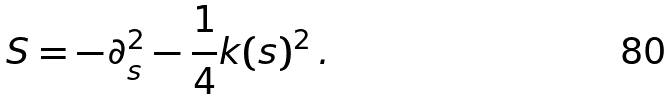<formula> <loc_0><loc_0><loc_500><loc_500>S = - \partial _ { s } ^ { 2 } - \frac { 1 } { 4 } k ( s ) ^ { 2 } \, .</formula> 